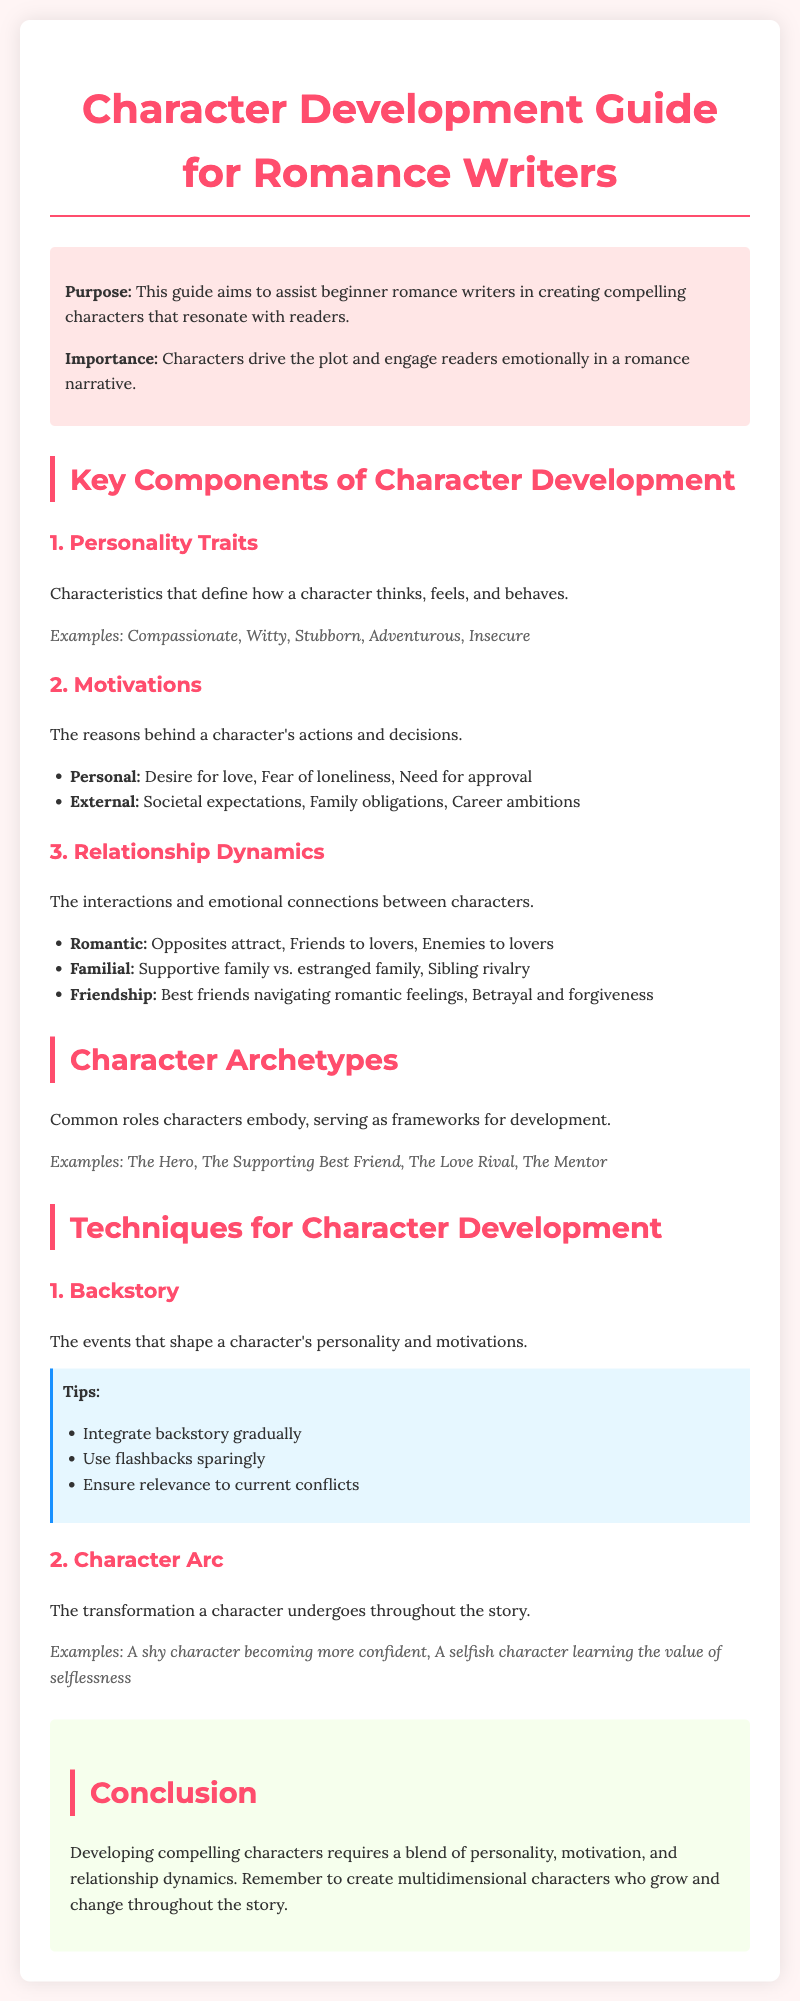What is the purpose of the guide? The purpose of the guide is to assist beginner romance writers in creating compelling characters that resonate with readers.
Answer: To assist beginner romance writers What are the three key components of character development? The three key components are Personality Traits, Motivations, and Relationship Dynamics.
Answer: Personality Traits, Motivations, Relationship Dynamics Name one example of a character archetype. An example of a character archetype is The Hero.
Answer: The Hero What should be integrated gradually in character development? Backstory should be integrated gradually in character development.
Answer: Backstory What type of relationship dynamic involves 'Opposites attract'? This type of relationship dynamic is classified as Romantic.
Answer: Romantic 